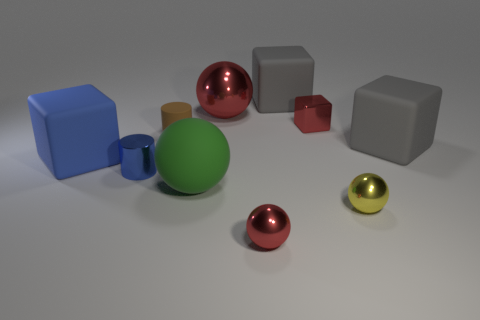Does the red object in front of the matte ball have the same size as the tiny yellow sphere?
Your answer should be compact. Yes. Is the number of gray rubber blocks on the left side of the large red metallic thing less than the number of red spheres?
Give a very brief answer. Yes. There is a blue cylinder that is the same size as the yellow metal object; what is it made of?
Offer a very short reply. Metal. What number of large things are brown balls or green spheres?
Your response must be concise. 1. What number of things are shiny things behind the red shiny block or large matte things in front of the metallic cube?
Offer a very short reply. 4. Is the number of tiny red cubes less than the number of tiny gray balls?
Ensure brevity in your answer.  No. There is a blue shiny object that is the same size as the rubber cylinder; what shape is it?
Make the answer very short. Cylinder. What number of other objects are the same color as the big metal ball?
Give a very brief answer. 2. What number of red shiny objects are there?
Your answer should be very brief. 3. How many tiny red objects are behind the blue cylinder and in front of the large blue rubber thing?
Ensure brevity in your answer.  0. 